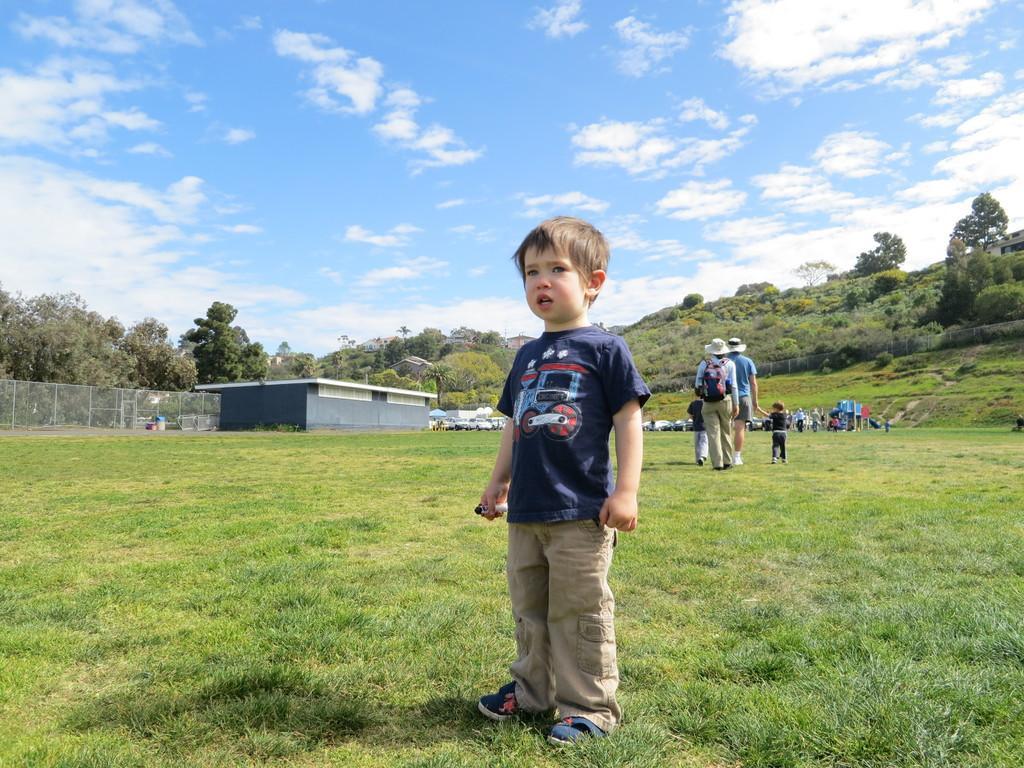Describe this image in one or two sentences. In this image we can see a few people on the ground, there are some trees, buildings, grass and vehicles, in the background we can see the sky with clouds. 